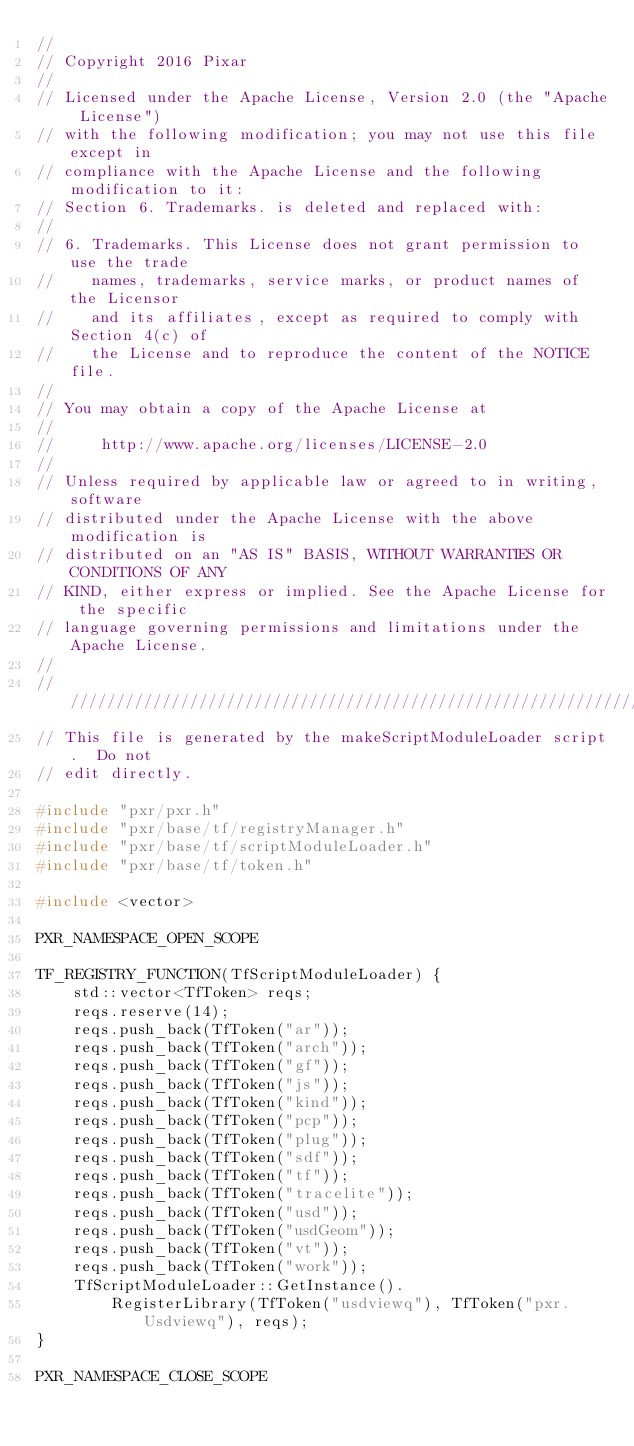Convert code to text. <code><loc_0><loc_0><loc_500><loc_500><_C++_>//
// Copyright 2016 Pixar
//
// Licensed under the Apache License, Version 2.0 (the "Apache License")
// with the following modification; you may not use this file except in
// compliance with the Apache License and the following modification to it:
// Section 6. Trademarks. is deleted and replaced with:
//
// 6. Trademarks. This License does not grant permission to use the trade
//    names, trademarks, service marks, or product names of the Licensor
//    and its affiliates, except as required to comply with Section 4(c) of
//    the License and to reproduce the content of the NOTICE file.
//
// You may obtain a copy of the Apache License at
//
//     http://www.apache.org/licenses/LICENSE-2.0
//
// Unless required by applicable law or agreed to in writing, software
// distributed under the Apache License with the above modification is
// distributed on an "AS IS" BASIS, WITHOUT WARRANTIES OR CONDITIONS OF ANY
// KIND, either express or implied. See the Apache License for the specific
// language governing permissions and limitations under the Apache License.
//
////////////////////////////////////////////////////////////////////////
// This file is generated by the makeScriptModuleLoader script.  Do not
// edit directly.

#include "pxr/pxr.h"
#include "pxr/base/tf/registryManager.h"
#include "pxr/base/tf/scriptModuleLoader.h"
#include "pxr/base/tf/token.h"

#include <vector>

PXR_NAMESPACE_OPEN_SCOPE

TF_REGISTRY_FUNCTION(TfScriptModuleLoader) {
    std::vector<TfToken> reqs;
    reqs.reserve(14);
    reqs.push_back(TfToken("ar"));
    reqs.push_back(TfToken("arch"));
    reqs.push_back(TfToken("gf"));
    reqs.push_back(TfToken("js"));
    reqs.push_back(TfToken("kind"));
    reqs.push_back(TfToken("pcp"));
    reqs.push_back(TfToken("plug"));
    reqs.push_back(TfToken("sdf"));
    reqs.push_back(TfToken("tf"));
    reqs.push_back(TfToken("tracelite"));
    reqs.push_back(TfToken("usd"));
    reqs.push_back(TfToken("usdGeom"));
    reqs.push_back(TfToken("vt"));
    reqs.push_back(TfToken("work"));
    TfScriptModuleLoader::GetInstance().
        RegisterLibrary(TfToken("usdviewq"), TfToken("pxr.Usdviewq"), reqs);
}

PXR_NAMESPACE_CLOSE_SCOPE


</code> 